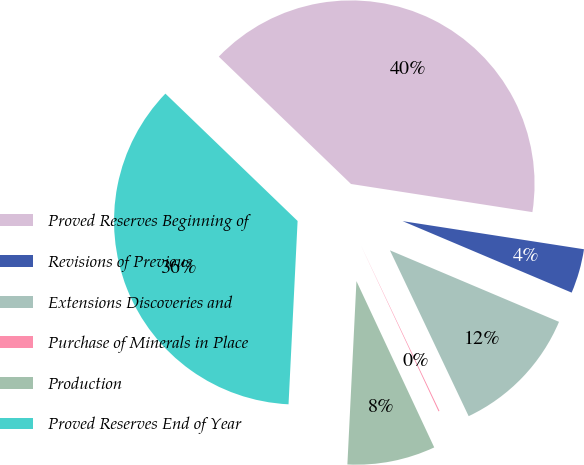Convert chart. <chart><loc_0><loc_0><loc_500><loc_500><pie_chart><fcel>Proved Reserves Beginning of<fcel>Revisions of Previous<fcel>Extensions Discoveries and<fcel>Purchase of Minerals in Place<fcel>Production<fcel>Proved Reserves End of Year<nl><fcel>40.25%<fcel>3.92%<fcel>11.58%<fcel>0.09%<fcel>7.75%<fcel>36.42%<nl></chart> 